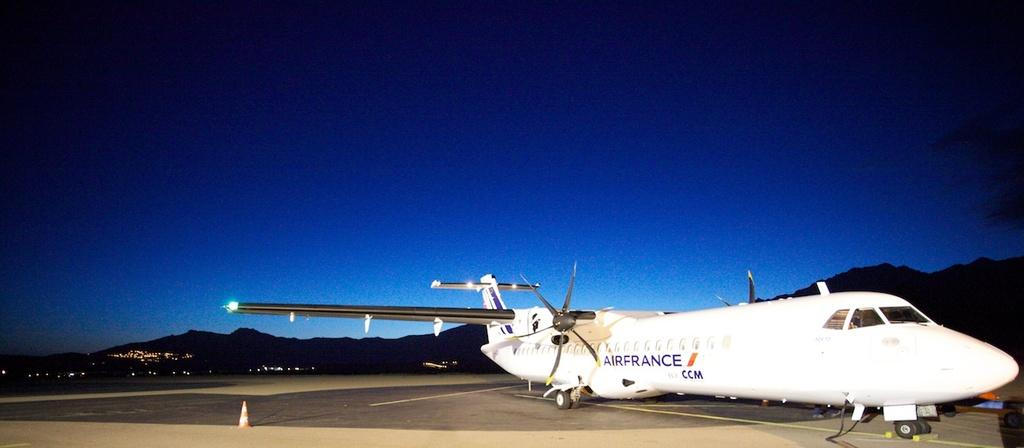<image>
Write a terse but informative summary of the picture. An Airfrance airplane sitting on the runway with mountains in the background. 